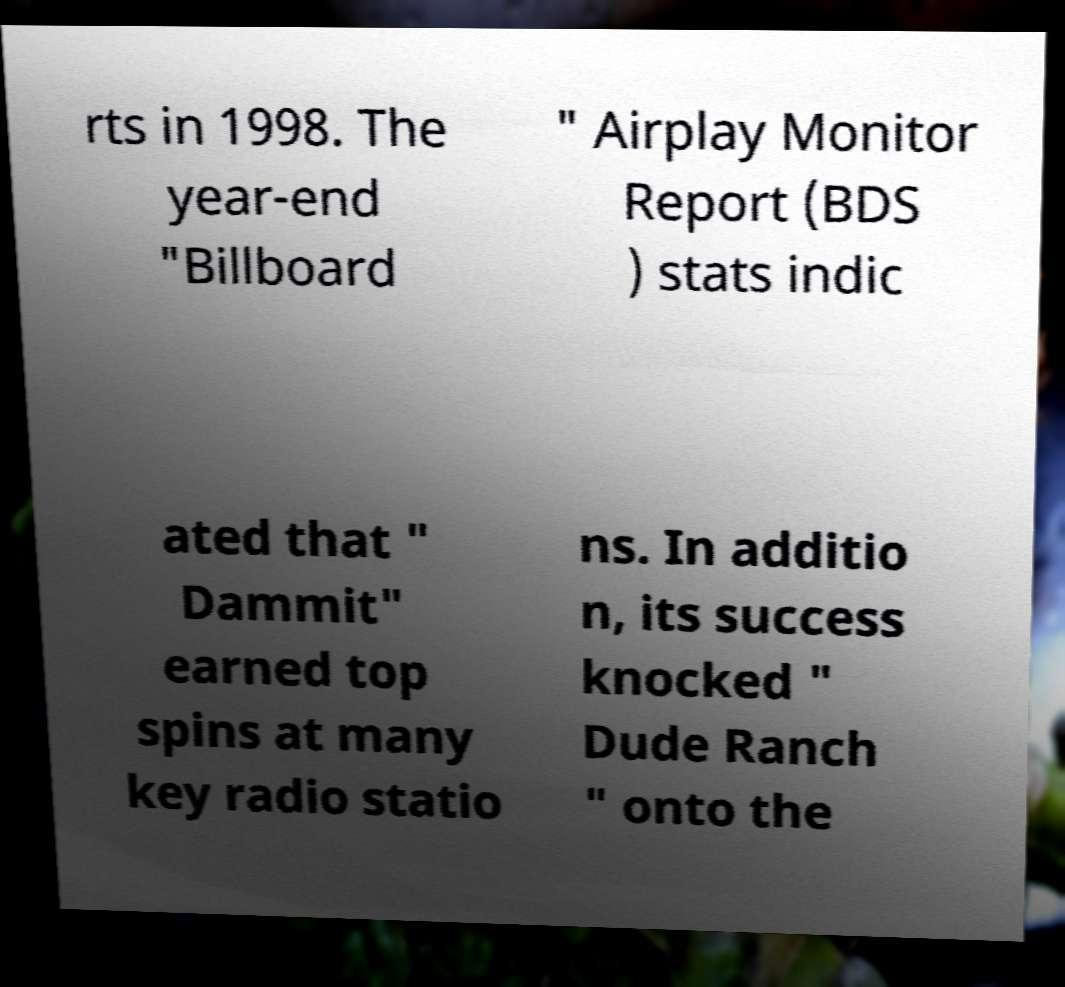Could you extract and type out the text from this image? rts in 1998. The year-end "Billboard " Airplay Monitor Report (BDS ) stats indic ated that " Dammit" earned top spins at many key radio statio ns. In additio n, its success knocked " Dude Ranch " onto the 